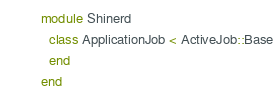Convert code to text. <code><loc_0><loc_0><loc_500><loc_500><_Ruby_>module Shinerd
  class ApplicationJob < ActiveJob::Base
  end
end
</code> 